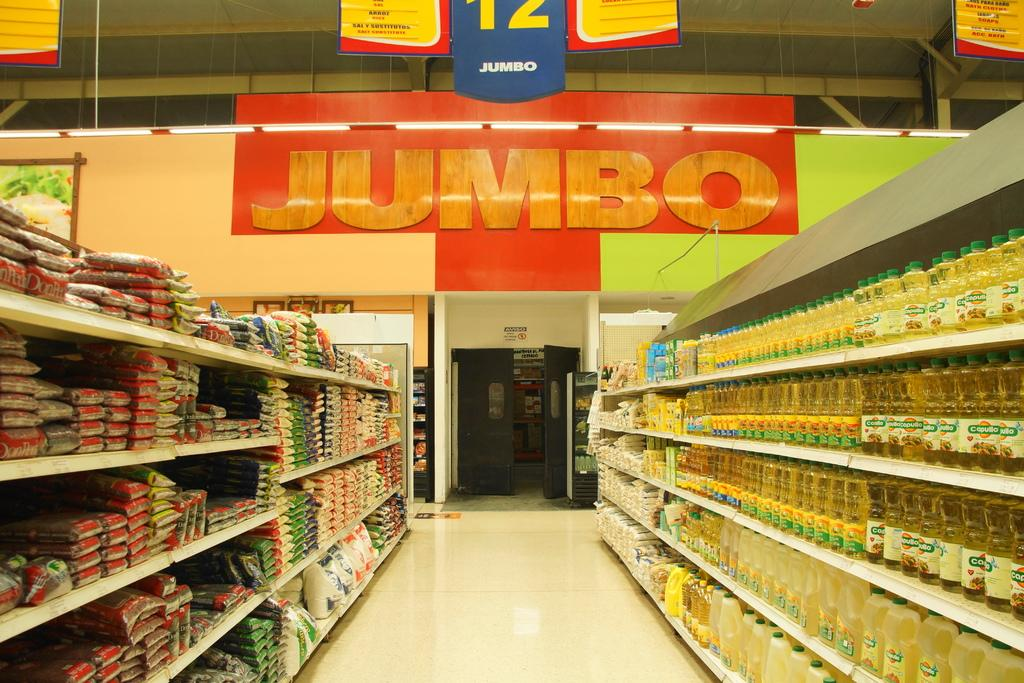Provide a one-sentence caption for the provided image. A food aisle in an empty Jumbo grocery store. 